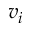<formula> <loc_0><loc_0><loc_500><loc_500>v _ { i }</formula> 